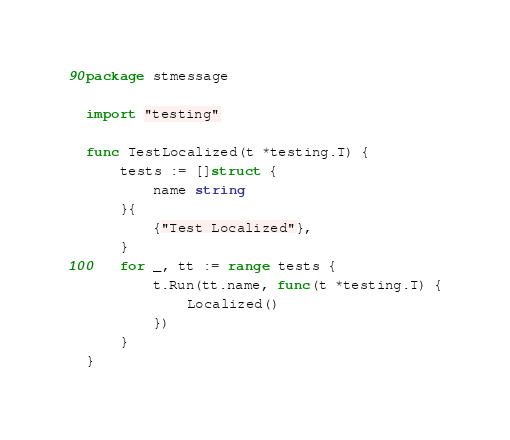Convert code to text. <code><loc_0><loc_0><loc_500><loc_500><_Go_>package stmessage

import "testing"

func TestLocalized(t *testing.T) {
	tests := []struct {
		name string
	}{
		{"Test Localized"},
	}
	for _, tt := range tests {
		t.Run(tt.name, func(t *testing.T) {
			Localized()
		})
	}
}
</code> 